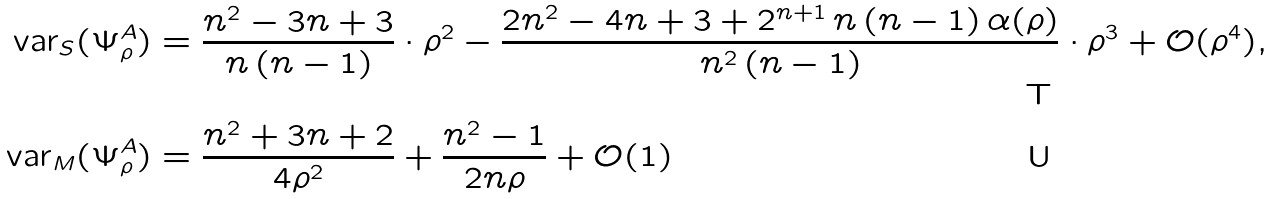Convert formula to latex. <formula><loc_0><loc_0><loc_500><loc_500>\text {var} _ { S } ( \Psi _ { \rho } ^ { A } ) & = \frac { n ^ { 2 } - 3 n + 3 } { n \, ( n - 1 ) } \cdot \rho ^ { 2 } - \frac { 2 n ^ { 2 } - 4 n + 3 + 2 ^ { n + 1 } \, n \, ( n - 1 ) \, \alpha ( \rho ) } { n ^ { 2 } \, ( n - 1 ) } \cdot \rho ^ { 3 } + \mathcal { O } ( \rho ^ { 4 } ) , \\ \text {var} _ { M } ( \Psi _ { \rho } ^ { A } ) & = \frac { n ^ { 2 } + 3 n + 2 } { 4 \rho ^ { 2 } } + \frac { n ^ { 2 } - 1 } { 2 n \rho } + \mathcal { O } ( 1 )</formula> 